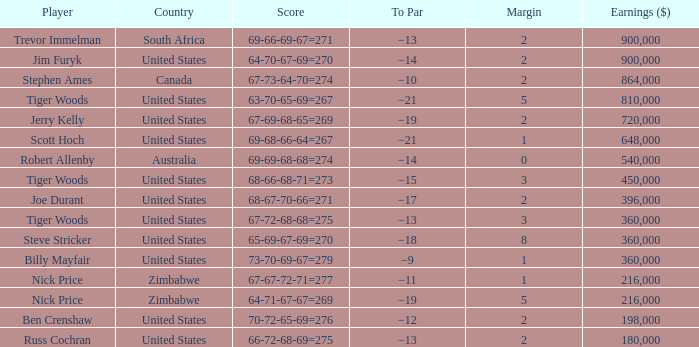Could you parse the entire table? {'header': ['Player', 'Country', 'Score', 'To Par', 'Margin', 'Earnings ($)'], 'rows': [['Trevor Immelman', 'South Africa', '69-66-69-67=271', '−13', '2', '900,000'], ['Jim Furyk', 'United States', '64-70-67-69=270', '−14', '2', '900,000'], ['Stephen Ames', 'Canada', '67-73-64-70=274', '−10', '2', '864,000'], ['Tiger Woods', 'United States', '63-70-65-69=267', '−21', '5', '810,000'], ['Jerry Kelly', 'United States', '67-69-68-65=269', '−19', '2', '720,000'], ['Scott Hoch', 'United States', '69-68-66-64=267', '−21', '1', '648,000'], ['Robert Allenby', 'Australia', '69-69-68-68=274', '−14', '0', '540,000'], ['Tiger Woods', 'United States', '68-66-68-71=273', '−15', '3', '450,000'], ['Joe Durant', 'United States', '68-67-70-66=271', '−17', '2', '396,000'], ['Tiger Woods', 'United States', '67-72-68-68=275', '−13', '3', '360,000'], ['Steve Stricker', 'United States', '65-69-67-69=270', '−18', '8', '360,000'], ['Billy Mayfair', 'United States', '73-70-69-67=279', '−9', '1', '360,000'], ['Nick Price', 'Zimbabwe', '67-67-72-71=277', '−11', '1', '216,000'], ['Nick Price', 'Zimbabwe', '64-71-67-67=269', '−19', '5', '216,000'], ['Ben Crenshaw', 'United States', '70-72-65-69=276', '−12', '2', '198,000'], ['Russ Cochran', 'United States', '66-72-68-69=275', '−13', '2', '180,000']]} Which to par has earnings ($) exceeding 360,000, and a year beyond 1998, and a country of united states, and a score of 69-68-66-64=267? −21. 